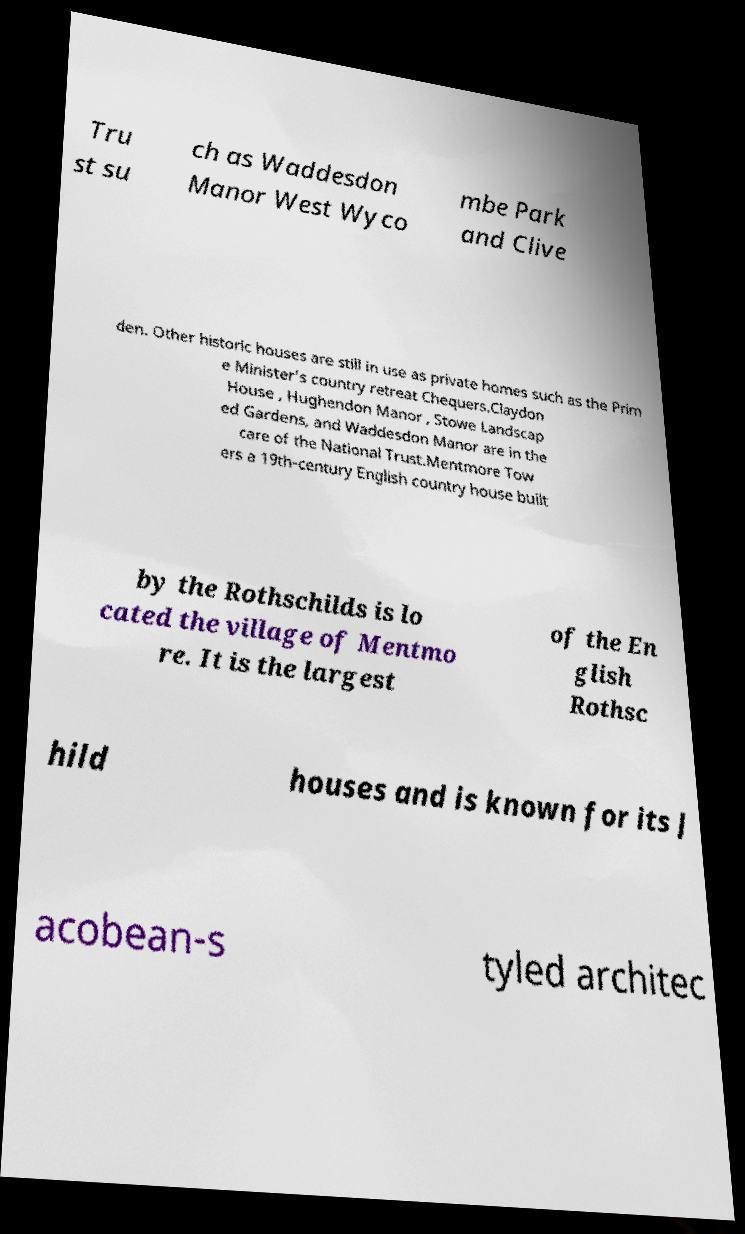Could you extract and type out the text from this image? Tru st su ch as Waddesdon Manor West Wyco mbe Park and Clive den. Other historic houses are still in use as private homes such as the Prim e Minister's country retreat Chequers.Claydon House , Hughendon Manor , Stowe Landscap ed Gardens, and Waddesdon Manor are in the care of the National Trust.Mentmore Tow ers a 19th-century English country house built by the Rothschilds is lo cated the village of Mentmo re. It is the largest of the En glish Rothsc hild houses and is known for its J acobean-s tyled architec 